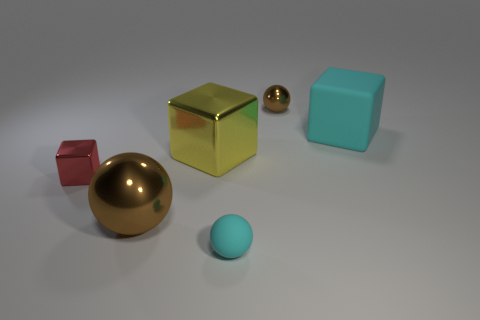Subtract all yellow cubes. How many cubes are left? 2 Add 1 small blue metal cylinders. How many objects exist? 7 Subtract 1 cubes. How many cubes are left? 2 Subtract all large purple rubber cylinders. Subtract all big matte objects. How many objects are left? 5 Add 1 small red objects. How many small red objects are left? 2 Add 1 purple shiny cylinders. How many purple shiny cylinders exist? 1 Subtract 0 purple spheres. How many objects are left? 6 Subtract all green blocks. Subtract all yellow balls. How many blocks are left? 3 